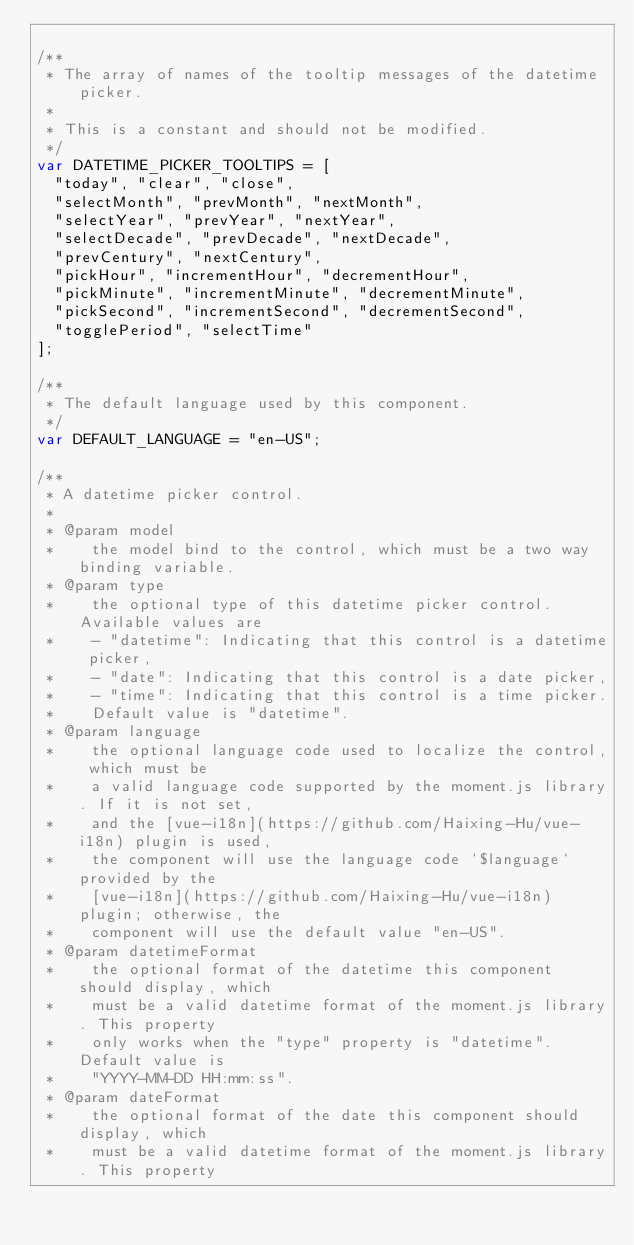<code> <loc_0><loc_0><loc_500><loc_500><_JavaScript_>
/**
 * The array of names of the tooltip messages of the datetime picker.
 *
 * This is a constant and should not be modified.
 */
var DATETIME_PICKER_TOOLTIPS = [
  "today", "clear", "close",
  "selectMonth", "prevMonth", "nextMonth",
  "selectYear", "prevYear", "nextYear",
  "selectDecade", "prevDecade", "nextDecade",
  "prevCentury", "nextCentury",
  "pickHour", "incrementHour", "decrementHour",
  "pickMinute", "incrementMinute", "decrementMinute",
  "pickSecond", "incrementSecond", "decrementSecond",
  "togglePeriod", "selectTime"
];

/**
 * The default language used by this component.
 */
var DEFAULT_LANGUAGE = "en-US";

/**
 * A datetime picker control.
 *
 * @param model
 *    the model bind to the control, which must be a two way binding variable.
 * @param type
 *    the optional type of this datetime picker control. Available values are
 *    - "datetime": Indicating that this control is a datetime picker,
 *    - "date": Indicating that this control is a date picker,
 *    - "time": Indicating that this control is a time picker.
 *    Default value is "datetime".
 * @param language
 *    the optional language code used to localize the control, which must be
 *    a valid language code supported by the moment.js library. If it is not set,
 *    and the [vue-i18n](https://github.com/Haixing-Hu/vue-i18n) plugin is used,
 *    the component will use the language code `$language` provided by the
 *    [vue-i18n](https://github.com/Haixing-Hu/vue-i18n) plugin; otherwise, the
 *    component will use the default value "en-US".
 * @param datetimeFormat
 *    the optional format of the datetime this component should display, which
 *    must be a valid datetime format of the moment.js library. This property
 *    only works when the "type" property is "datetime". Default value is
 *    "YYYY-MM-DD HH:mm:ss".
 * @param dateFormat
 *    the optional format of the date this component should display, which
 *    must be a valid datetime format of the moment.js library. This property</code> 